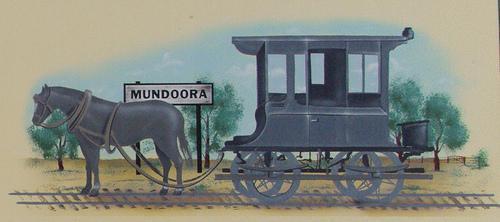How many horses are hitched to the buggy?
Give a very brief answer. 1. How many wheels does the buggy have?
Give a very brief answer. 4. 